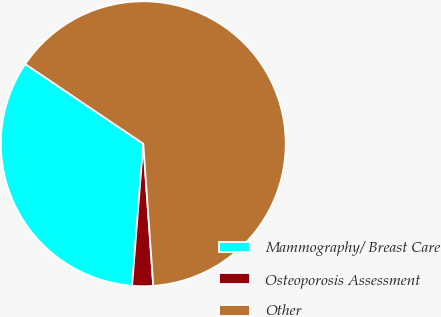Convert chart to OTSL. <chart><loc_0><loc_0><loc_500><loc_500><pie_chart><fcel>Mammography/ Breast Care<fcel>Osteoporosis Assessment<fcel>Other<nl><fcel>33.2%<fcel>2.37%<fcel>64.43%<nl></chart> 